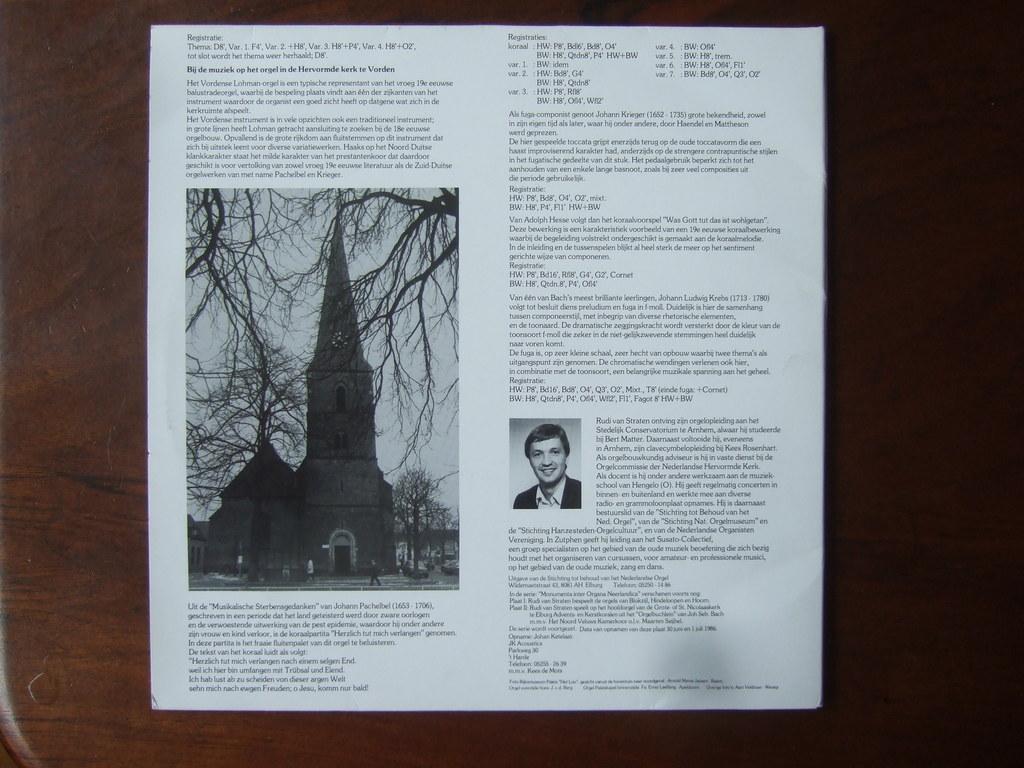Please provide a concise description of this image. In this image, we can see a paper on the wooden surface contains pictures and some text. 